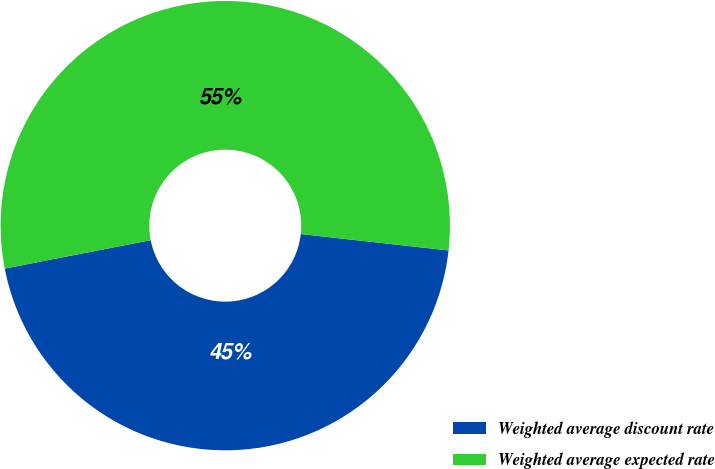Convert chart to OTSL. <chart><loc_0><loc_0><loc_500><loc_500><pie_chart><fcel>Weighted average discount rate<fcel>Weighted average expected rate<nl><fcel>45.18%<fcel>54.82%<nl></chart> 